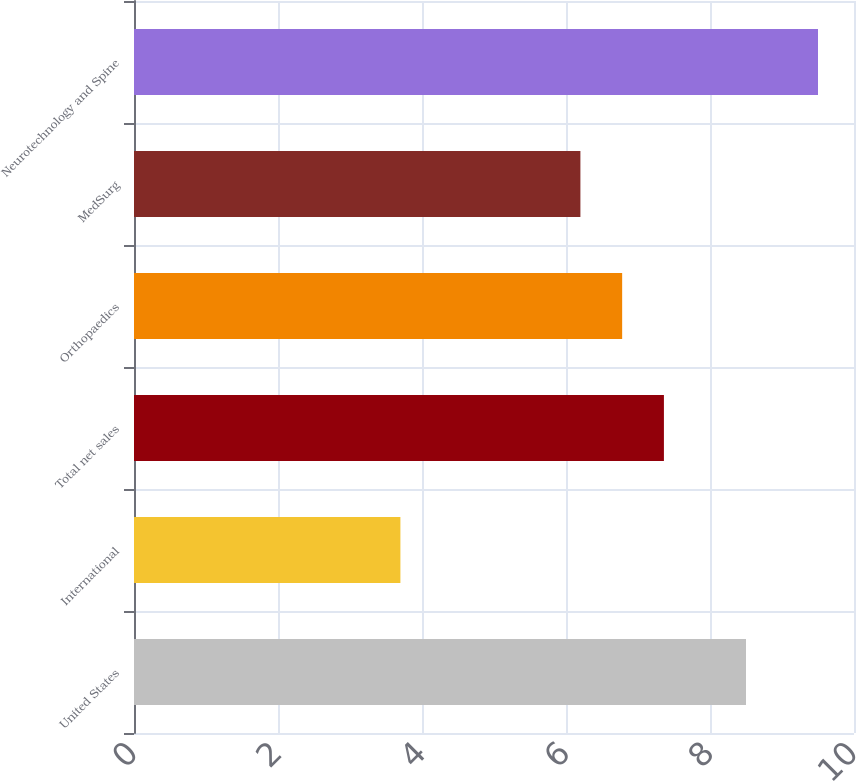<chart> <loc_0><loc_0><loc_500><loc_500><bar_chart><fcel>United States<fcel>International<fcel>Total net sales<fcel>Orthopaedics<fcel>MedSurg<fcel>Neurotechnology and Spine<nl><fcel>8.5<fcel>3.7<fcel>7.36<fcel>6.78<fcel>6.2<fcel>9.5<nl></chart> 